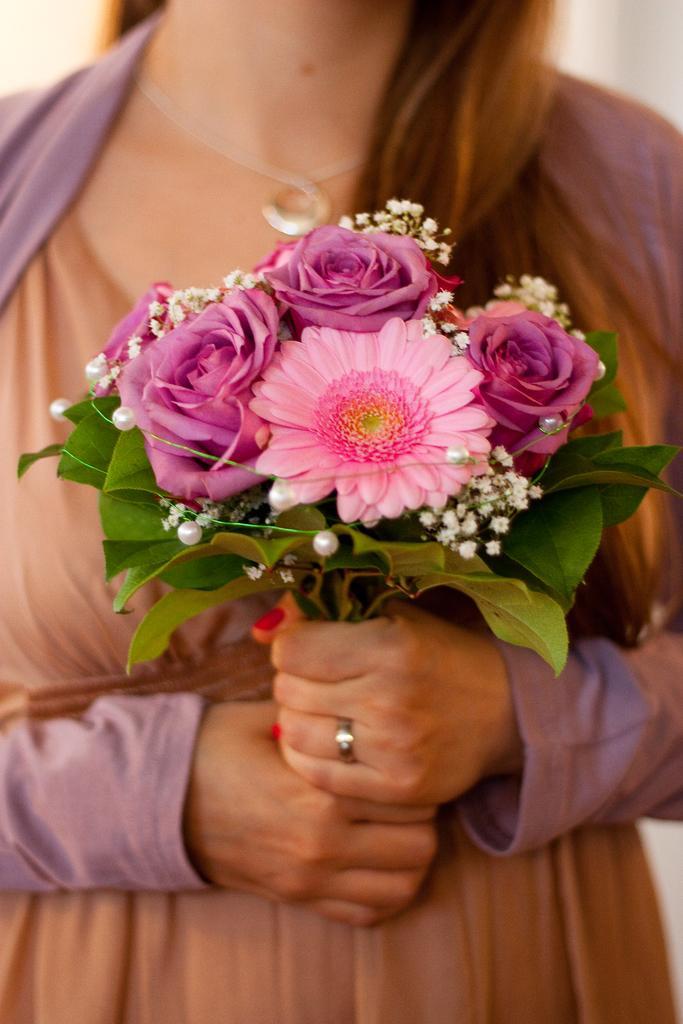Could you give a brief overview of what you see in this image? In this image I can see a woman wearing brown and pink colored dress is standing and holding a flower bouquet in her hand. I can see few flowers which are pink and white in color. I can see the white colored background. 